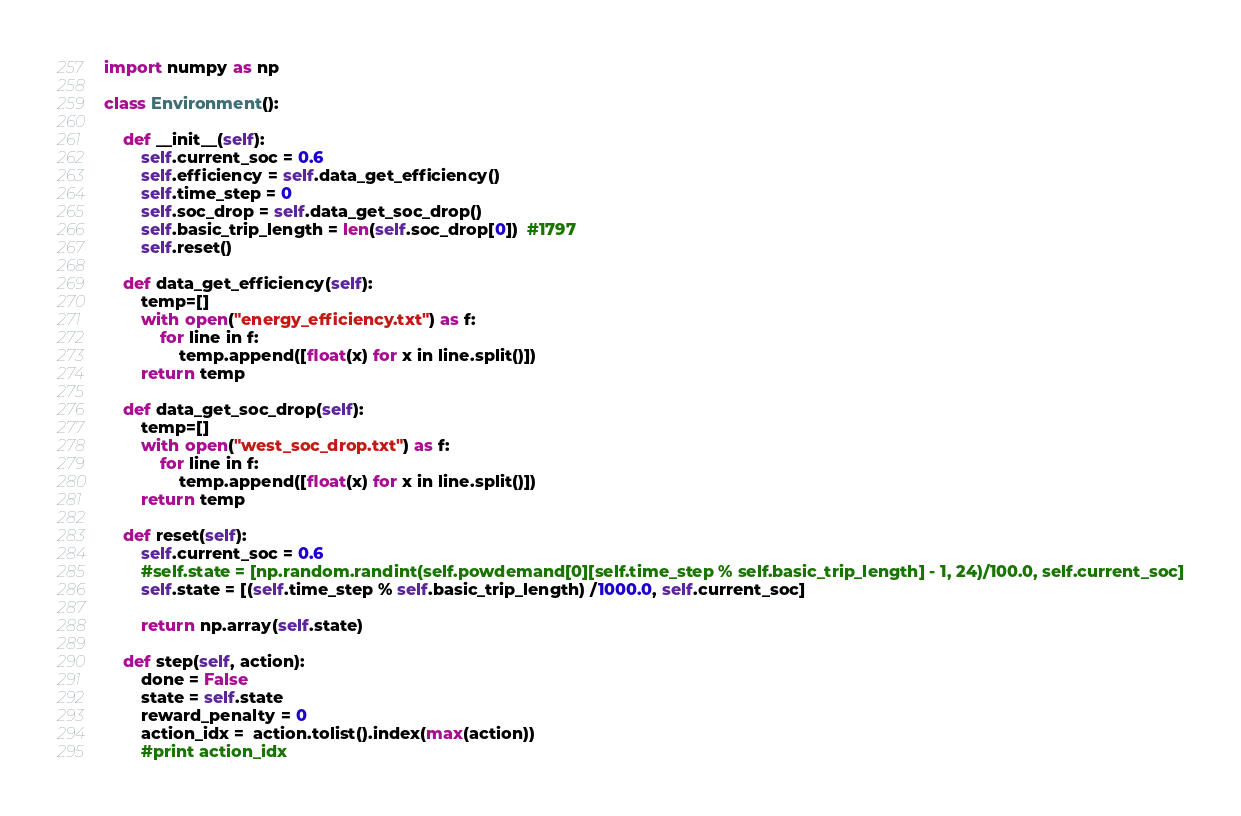Convert code to text. <code><loc_0><loc_0><loc_500><loc_500><_Python_>import numpy as np

class Environment():

    def __init__(self):
        self.current_soc = 0.6
        self.efficiency = self.data_get_efficiency()
        self.time_step = 0
        self.soc_drop = self.data_get_soc_drop()
        self.basic_trip_length = len(self.soc_drop[0])  #1797
        self.reset()
        
    def data_get_efficiency(self):
        temp=[]
        with open("energy_efficiency.txt") as f:
            for line in f:
                temp.append([float(x) for x in line.split()])
        return temp

    def data_get_soc_drop(self):
        temp=[]
        with open("west_soc_drop.txt") as f:
            for line in f:
                temp.append([float(x) for x in line.split()])
        return temp

    def reset(self):
        self.current_soc = 0.6
        #self.state = [np.random.randint(self.powdemand[0][self.time_step % self.basic_trip_length] - 1, 24)/100.0, self.current_soc]
        self.state = [(self.time_step % self.basic_trip_length) /1000.0, self.current_soc]
        
        return np.array(self.state)
        
    def step(self, action):
        done = False
        state = self.state
        reward_penalty = 0
        action_idx =  action.tolist().index(max(action))
        #print action_idx</code> 